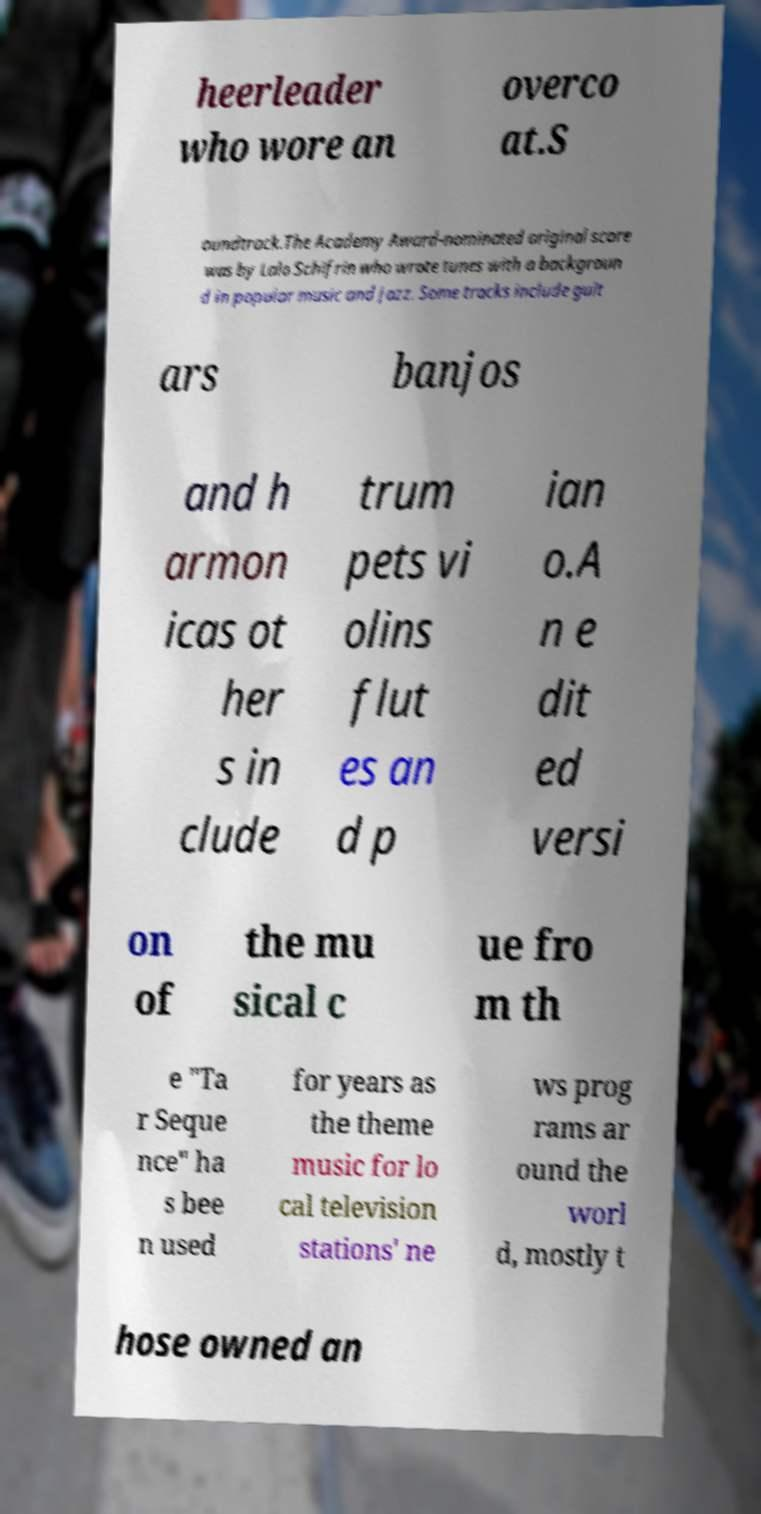I need the written content from this picture converted into text. Can you do that? heerleader who wore an overco at.S oundtrack.The Academy Award-nominated original score was by Lalo Schifrin who wrote tunes with a backgroun d in popular music and jazz. Some tracks include guit ars banjos and h armon icas ot her s in clude trum pets vi olins flut es an d p ian o.A n e dit ed versi on of the mu sical c ue fro m th e "Ta r Seque nce" ha s bee n used for years as the theme music for lo cal television stations' ne ws prog rams ar ound the worl d, mostly t hose owned an 